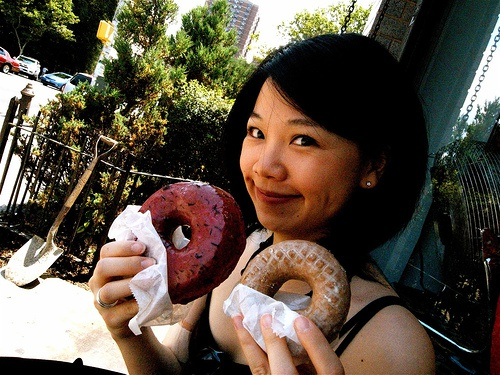Describe the objects in this image and their specific colors. I can see people in olive, black, maroon, gray, and tan tones, donut in olive, black, maroon, and brown tones, donut in olive, gray, brown, maroon, and darkgray tones, car in olive, white, black, darkgray, and gray tones, and car in olive, white, black, lightblue, and darkgray tones in this image. 